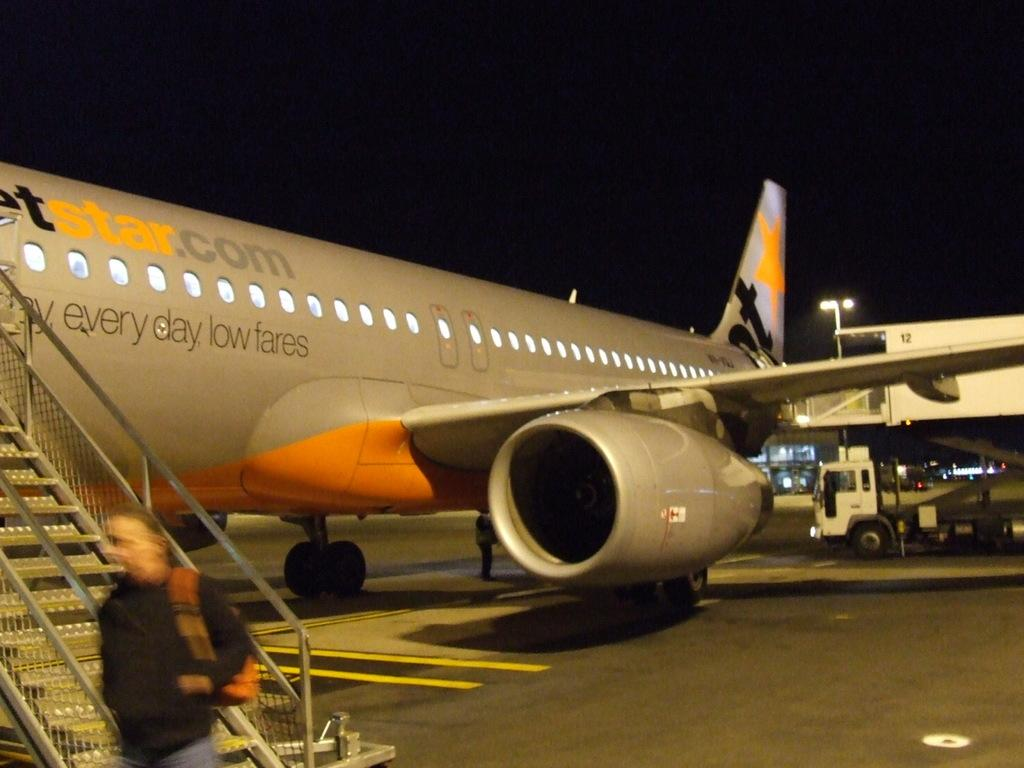Provide a one-sentence caption for the provided image. A plan displaying a message for every day low fares. 